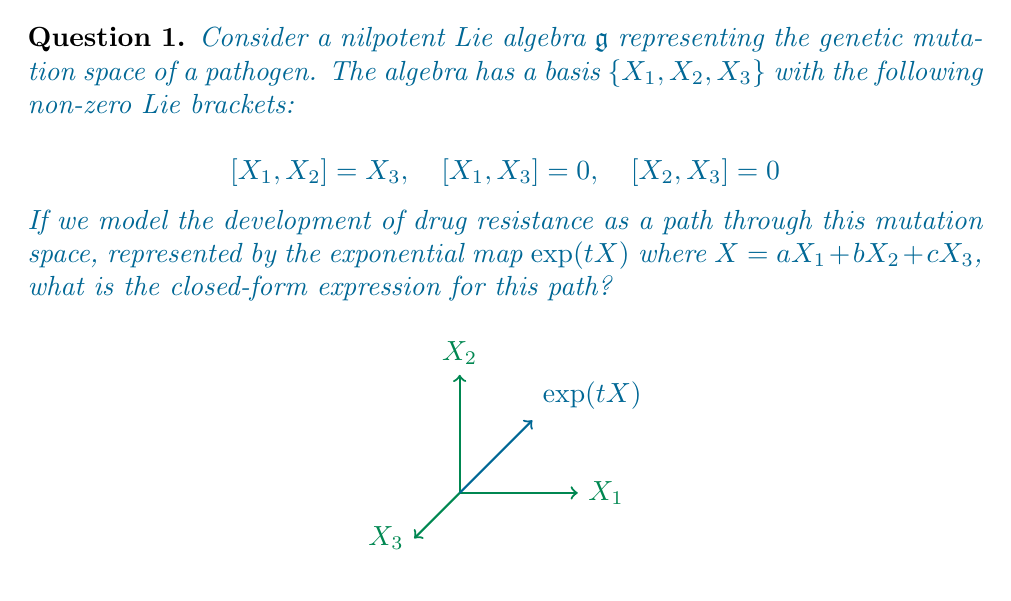Solve this math problem. To solve this problem, we'll use the Baker-Campbell-Hausdorff formula for nilpotent Lie algebras. The steps are as follows:

1) First, recall that for a nilpotent Lie algebra of step 2 (where all double brackets are zero), the BCH formula simplifies to:

   $$\exp(X) = I + X + \frac{1}{2}[X,X]$$

2) In our case, $X = aX_1 + bX_2 + cX_3$. Let's compute $[X,X]$:

   $$[X,X] = [aX_1 + bX_2 + cX_3, aX_1 + bX_2 + cX_3]$$

3) Expanding this using the bilinearity of the Lie bracket:

   $$[X,X] = a^2[X_1,X_1] + ab[X_1,X_2] + ac[X_1,X_3] + ba[X_2,X_1] + b^2[X_2,X_2] + bc[X_2,X_3] + ca[X_3,X_1] + cb[X_3,X_2] + c^2[X_3,X_3]$$

4) Using the given Lie bracket relations and the anti-symmetry of the Lie bracket:

   $$[X,X] = ab[X_1,X_2] - ba[X_2,X_1] = 2ab[X_1,X_2] = 2abX_3$$

5) Substituting this back into the BCH formula:

   $$\exp(X) = I + (aX_1 + bX_2 + cX_3) + \frac{1}{2}(2abX_3)$$

6) Simplifying:

   $$\exp(X) = I + aX_1 + bX_2 + (c + ab)X_3$$

7) Finally, to get the path $\exp(tX)$, we replace $a$, $b$, and $c$ with $at$, $bt$, and $ct$ respectively:

   $$\exp(tX) = I + atX_1 + btX_2 + (ct + abt^2)X_3$$

This is the closed-form expression for the path through the mutation space.
Answer: $\exp(tX) = I + atX_1 + btX_2 + (ct + abt^2)X_3$ 